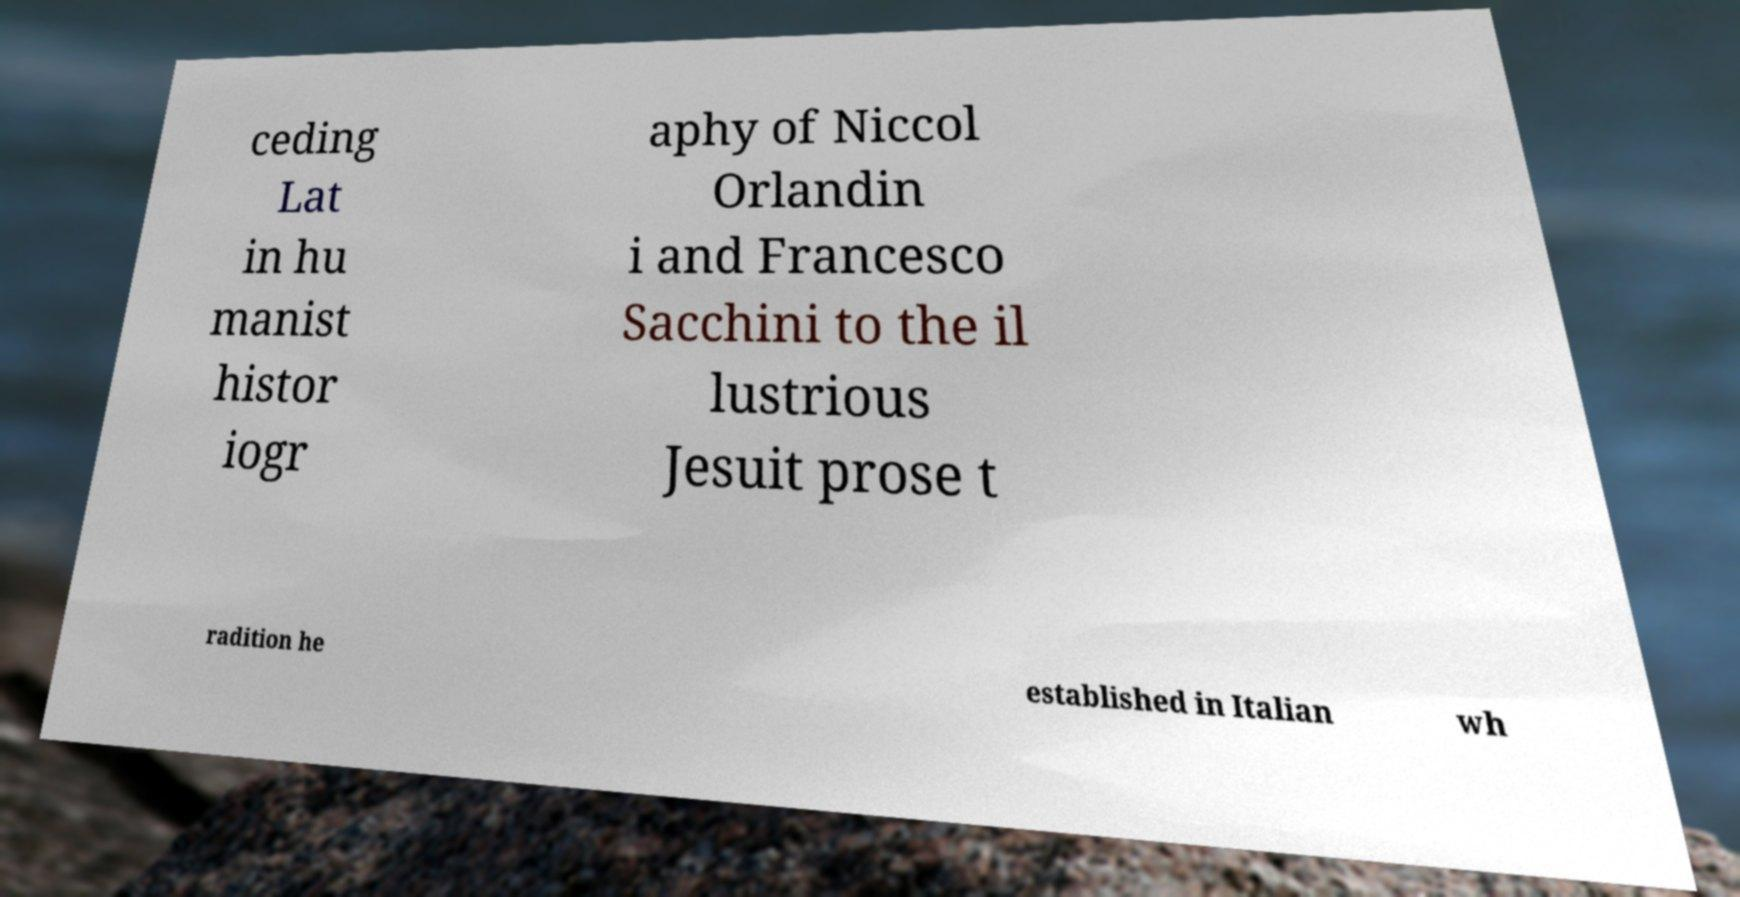I need the written content from this picture converted into text. Can you do that? ceding Lat in hu manist histor iogr aphy of Niccol Orlandin i and Francesco Sacchini to the il lustrious Jesuit prose t radition he established in Italian wh 